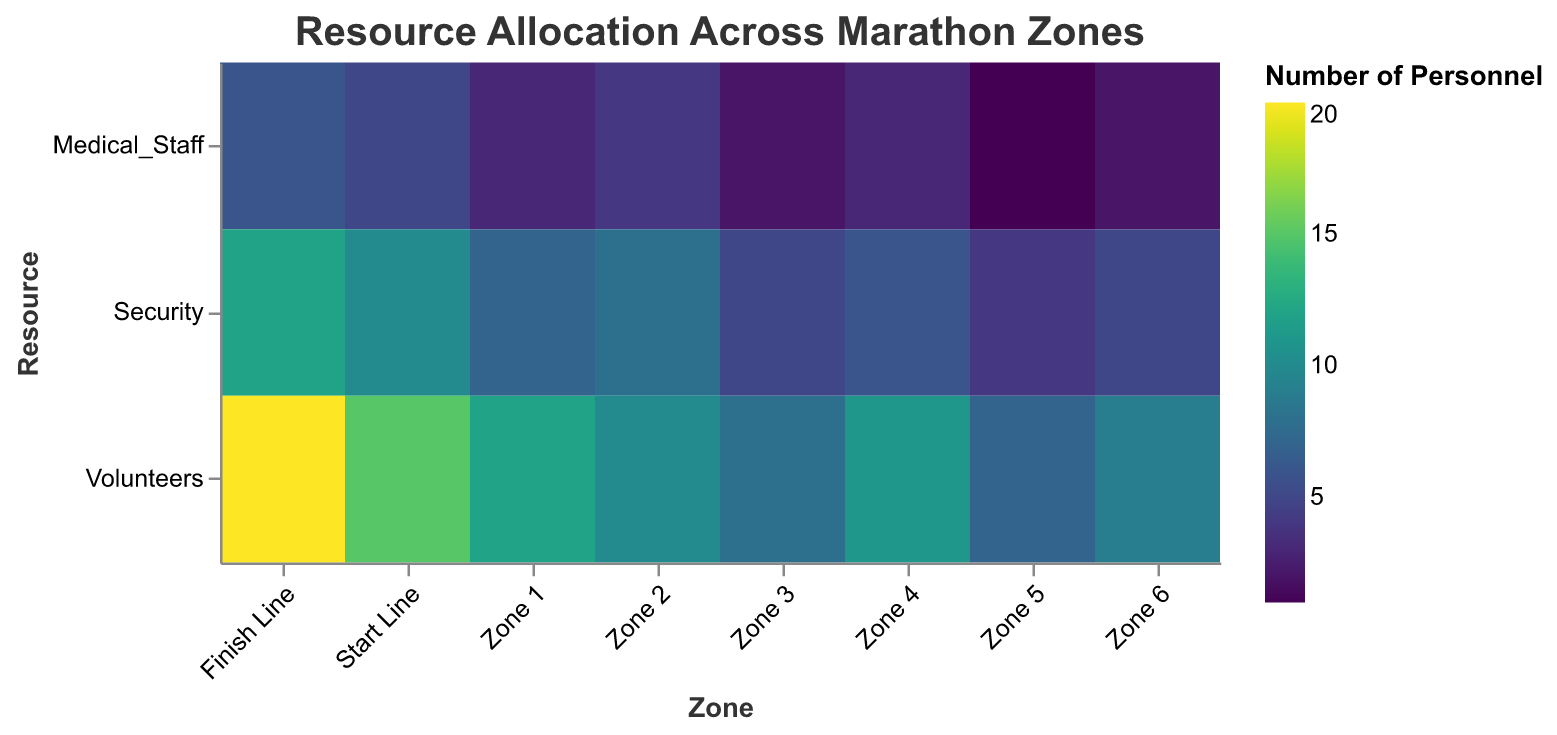what is the title of the heatmap? The title of the heatmap is located at the top of the figure. It indicates what's being displayed in the heatmap. The title is "Resource Allocation Across Marathon Zones".
Answer: Resource Allocation Across Marathon Zones Which zone has the highest number of medical staff? To find the zone with the highest number of medical staff, look for the zone with the darkest shade corresponding to Medical_Staff. The Finish Line has the darkest shade indicating 6 medical staff.
Answer: Finish Line What is the total number of volunteers in Zone 2 and Zone 3? Sum the number of volunteers in Zone 2 and Zone 3. Zone 2 has 10 volunteers and Zone 3 has 8 volunteers. The total is \(10 + 8 = 18\).
Answer: 18 Which zone has fewer security personnel, Zone 5 or Zone 6? Compare the number of security personnel between Zone 5 and Zone 6. Zone 5 has 4 security personnel while Zone 6 has 5. Thus, Zone 5 has fewer security personnel.
Answer: Zone 5 What is the average number of medical staff across all zones? To find the average number of medical staff, sum the number of medical staff for all zones and divide by the number of zones (8). The sum of medical staff is \(5 + 3 + 4 + 2 + 3 + 1 + 2 + 6 = 26\). The average is \(\frac{26}{8} = 3.25\).
Answer: 3.25 Which resource is most allocated at the Start Line? Examine the color intensity for each resource at the Start Line. The darkest shade corresponds to Volunteers with 15, indicating that it is the most allocated resource.
Answer: Volunteers Between Zone 1 and Zone 4, which has more total personnel allocated? Sum the number of personnel (medical staff, security, and volunteers) for Zone 1 and Zone 4. Zone 1: \(3 + 7 + 12 = 22\). Zone 4: \(3 + 6 + 11 = 20\). Zone 1 has more personnel allocated.
Answer: Zone 1 What is the difference in the number of security personnel between Start Line and Finish Line? Subtract the number of security personnel at the Start Line from that at the Finish Line. Finish Line has 12 and Start Line has 10 security personnel. The difference is \(12 - 10 = 2\).
Answer: 2 At which stage is there the lowest number of volunteers? Identify the lightest shade corresponding to Volunteers. Zone 5 has the lightest shade for Volunteers with 7 individuals.
Answer: Zone 5 